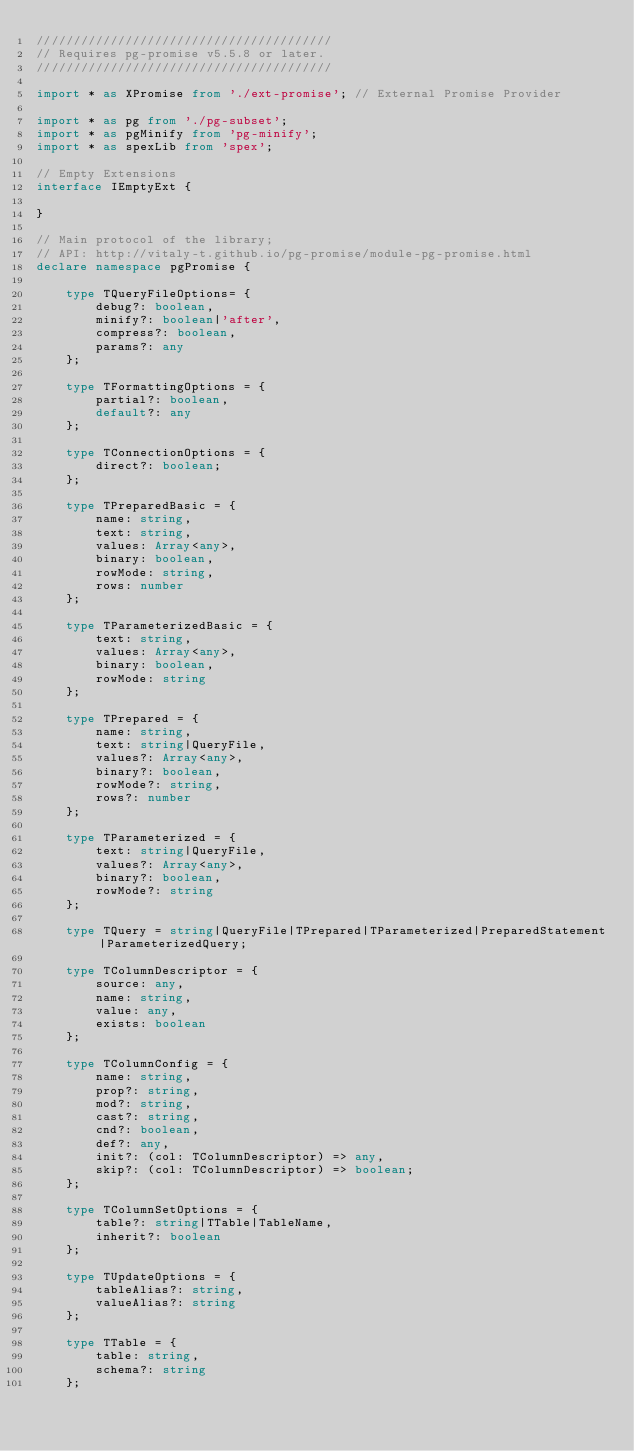Convert code to text. <code><loc_0><loc_0><loc_500><loc_500><_TypeScript_>////////////////////////////////////////
// Requires pg-promise v5.5.8 or later.
////////////////////////////////////////

import * as XPromise from './ext-promise'; // External Promise Provider

import * as pg from './pg-subset';
import * as pgMinify from 'pg-minify';
import * as spexLib from 'spex';

// Empty Extensions
interface IEmptyExt {

}

// Main protocol of the library;
// API: http://vitaly-t.github.io/pg-promise/module-pg-promise.html
declare namespace pgPromise {

    type TQueryFileOptions= {
        debug?: boolean,
        minify?: boolean|'after',
        compress?: boolean,
        params?: any
    };

    type TFormattingOptions = {
        partial?: boolean,
        default?: any
    };

    type TConnectionOptions = {
        direct?: boolean;
    };

    type TPreparedBasic = {
        name: string,
        text: string,
        values: Array<any>,
        binary: boolean,
        rowMode: string,
        rows: number
    };

    type TParameterizedBasic = {
        text: string,
        values: Array<any>,
        binary: boolean,
        rowMode: string
    };

    type TPrepared = {
        name: string,
        text: string|QueryFile,
        values?: Array<any>,
        binary?: boolean,
        rowMode?: string,
        rows?: number
    };

    type TParameterized = {
        text: string|QueryFile,
        values?: Array<any>,
        binary?: boolean,
        rowMode?: string
    };

    type TQuery = string|QueryFile|TPrepared|TParameterized|PreparedStatement|ParameterizedQuery;

    type TColumnDescriptor = {
        source: any,
        name: string,
        value: any,
        exists: boolean
    };

    type TColumnConfig = {
        name: string,
        prop?: string,
        mod?: string,
        cast?: string,
        cnd?: boolean,
        def?: any,
        init?: (col: TColumnDescriptor) => any,
        skip?: (col: TColumnDescriptor) => boolean;
    };

    type TColumnSetOptions = {
        table?: string|TTable|TableName,
        inherit?: boolean
    };

    type TUpdateOptions = {
        tableAlias?: string,
        valueAlias?: string
    };

    type TTable = {
        table: string,
        schema?: string
    };
</code> 